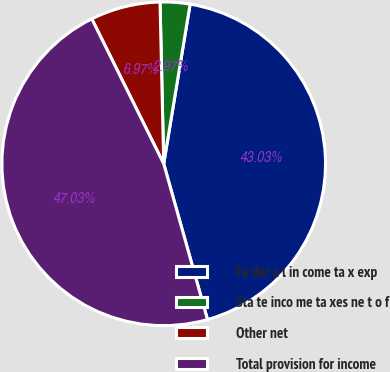Convert chart. <chart><loc_0><loc_0><loc_500><loc_500><pie_chart><fcel>Fe der a l in come ta x exp<fcel>Sta te inco me ta xes ne t o f<fcel>Other net<fcel>Total provision for income<nl><fcel>43.03%<fcel>2.97%<fcel>6.97%<fcel>47.03%<nl></chart> 